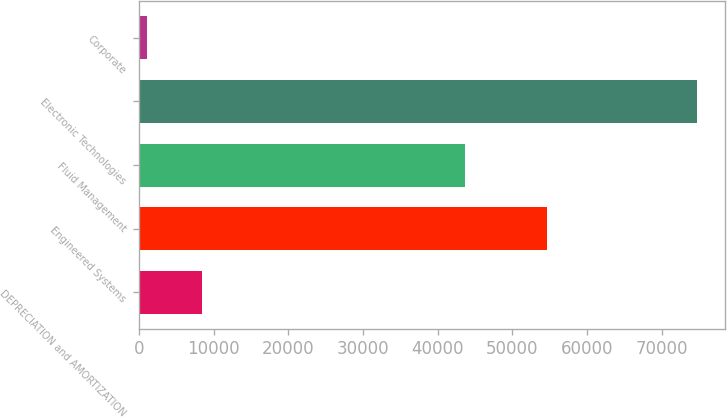Convert chart to OTSL. <chart><loc_0><loc_0><loc_500><loc_500><bar_chart><fcel>DEPRECIATION and AMORTIZATION<fcel>Engineered Systems<fcel>Fluid Management<fcel>Electronic Technologies<fcel>Corporate<nl><fcel>8405.3<fcel>54580<fcel>43700<fcel>74720<fcel>1037<nl></chart> 